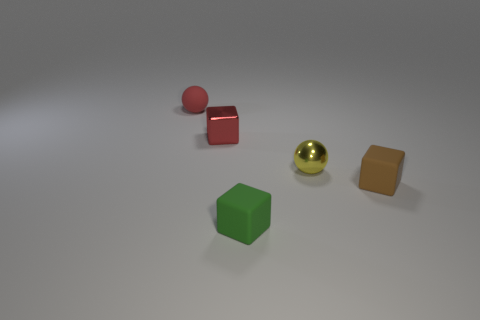Add 3 tiny spheres. How many objects exist? 8 Subtract all green spheres. Subtract all red cylinders. How many spheres are left? 2 Subtract all cubes. How many objects are left? 2 Add 1 tiny yellow metallic things. How many tiny yellow metallic things are left? 2 Add 1 red rubber things. How many red rubber things exist? 2 Subtract 0 purple cylinders. How many objects are left? 5 Subtract all large cyan matte cubes. Subtract all tiny red things. How many objects are left? 3 